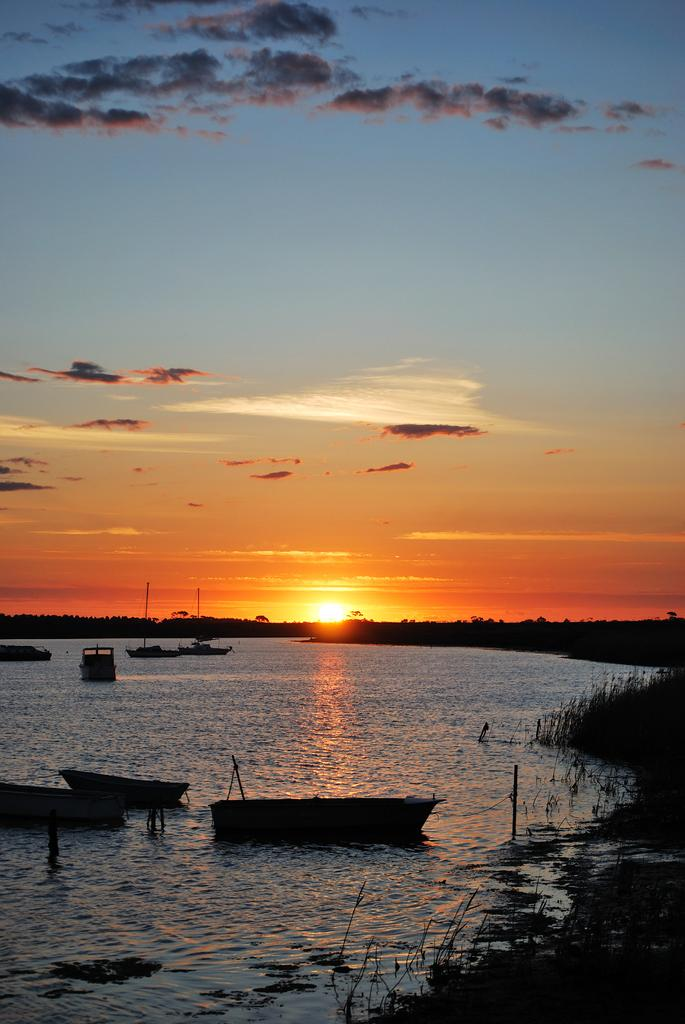What body of water is present at the bottom of the image? There is a river at the bottom of the image. What is in the river? There are boats in the river. What is visible at the top of the image? The sky is visible at the top of the image, and the sun is present. What type of vegetation is on the right side of the image? There is grass on the right side of the image. What type of rhythm can be heard coming from the boats in the image? There is no sound or rhythm present in the image; it is a still image of a river with boats. How many pizzas are being delivered by the boats in the image? There are no pizzas or delivery services depicted in the image; it features a river with boats and a grassy area on the right side. 